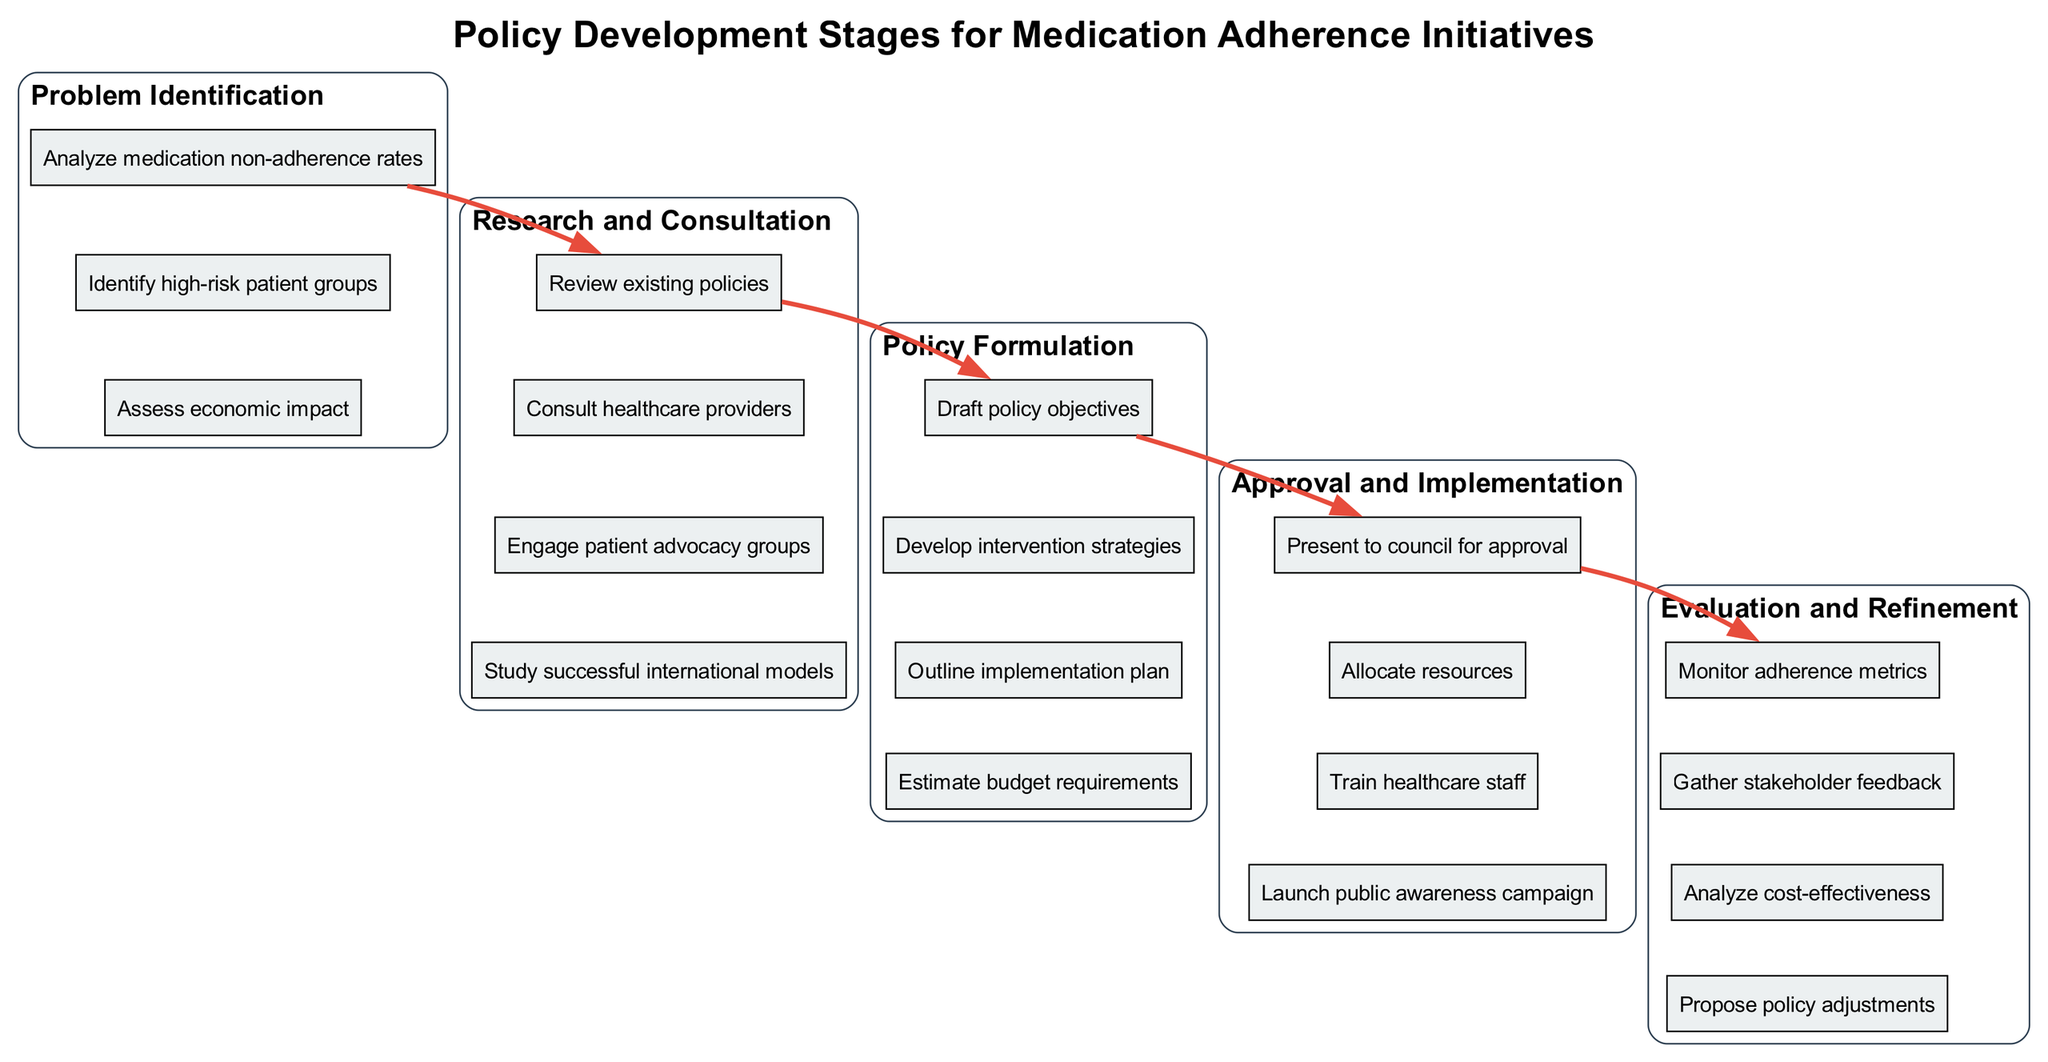What is the first tier in the policy development stages? The first tier listed in the diagram is "Problem Identification," which is specifically mentioned as the uppermost tier in the multi-tiered structure.
Answer: Problem Identification How many elements are in the "Research and Consultation" tier? The "Research and Consultation" tier contains four elements as stated in the diagram.
Answer: 4 What is the final step in the "Evaluation and Refinement" stage? The last element listed in the "Evaluation and Refinement" tier is "Propose policy adjustments," which indicates the concluding activity in this stage.
Answer: Propose policy adjustments Which two tiers does the edge connect directly? The edge connects the tiers "Policy Formulation" and "Approval and Implementation," as indicated by the arrows moving from the last element of the first tier to the first element of the subsequent tier.
Answer: Policy Formulation and Approval and Implementation What element involves engaging stakeholders in the policy development? The element "Engage patient advocacy groups" from the "Research and Consultation" tier involves engaging stakeholders as part of the consultation process.
Answer: Engage patient advocacy groups Discuss the purpose of the "Draft policy objectives" in the policy formulation stage. "Draft policy objectives" is aimed at setting clear goals for the medication adherence initiative, forming a critical part of the policy formulation process. This ensures that the policy is aligned with the overall objectives of improving medication adherence.
Answer: Set clear goals for the initiative How does "Analyze medication non-adherence rates" affect subsequent policy stages? Analyzing medication non-adherence rates helps to identify the core issues that need to be addressed in later stages, influencing both the formulation of policies and the development of effective intervention strategies.
Answer: Influences policy formulation and intervention strategies What is the main goal of the "Launch public awareness campaign" step? The main goal of launching a public awareness campaign is to inform the community about the policy and encourage adherence to medication regimens among patients.
Answer: Encourage adherence to medication regimens What process follows the presentation to the council for approval? The process that follows is "Allocate resources," which is a critical step needed to implement the approved policy effectively.
Answer: Allocate resources What is the relationship between "Monitor adherence metrics" and "Gather stakeholder feedback"? "Monitor adherence metrics" and "Gather stakeholder feedback" are both components of the evaluation stage that serve to measure the effectiveness of the policy while also collecting insights from those affected, hence improving future iterations of the policy.
Answer: Measure effectiveness and collect insights 